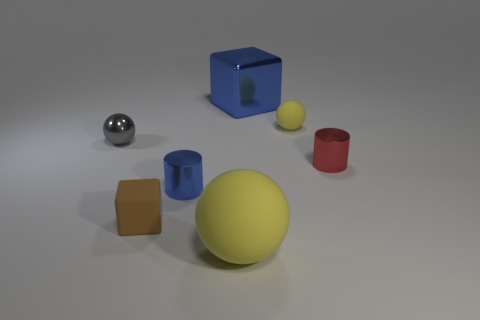What time of day does the lighting in this image suggest? The image does not offer strong indicators of a particular time of day, as it seems to be a studio setup with artificial lighting, given the uniformity of light and lack of natural elements or context. 